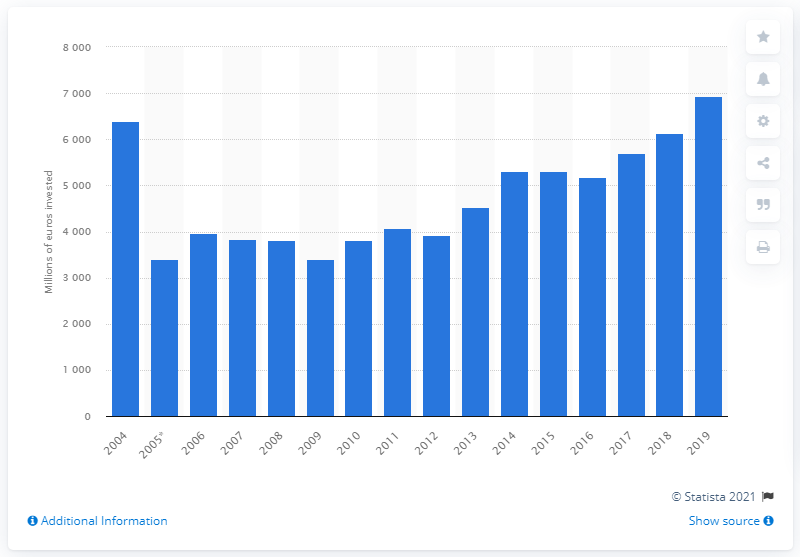Draw attention to some important aspects in this diagram. According to data from 2019, a total of 6,948 million euros was invested in rail transport infrastructure in Germany. In 2019, the largest amount of investments was recorded in the recorded time period. 